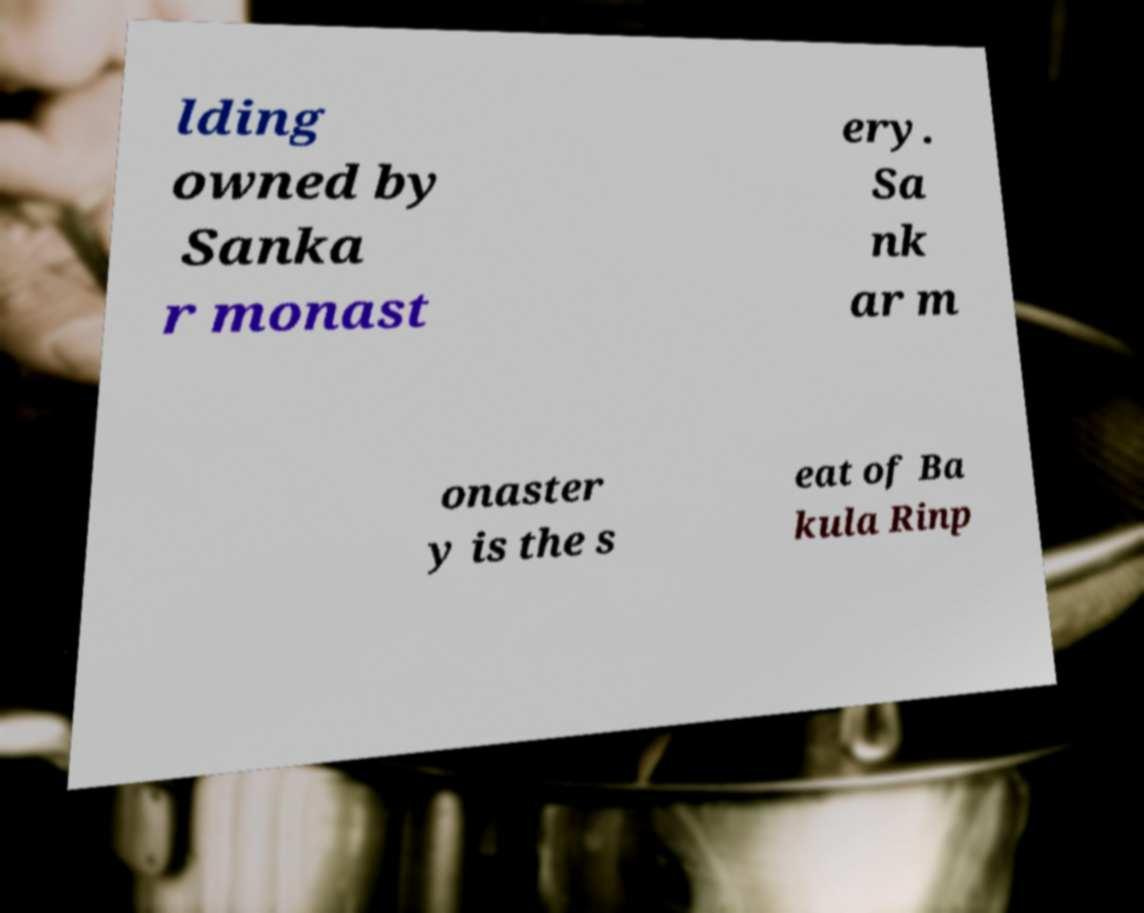I need the written content from this picture converted into text. Can you do that? lding owned by Sanka r monast ery. Sa nk ar m onaster y is the s eat of Ba kula Rinp 